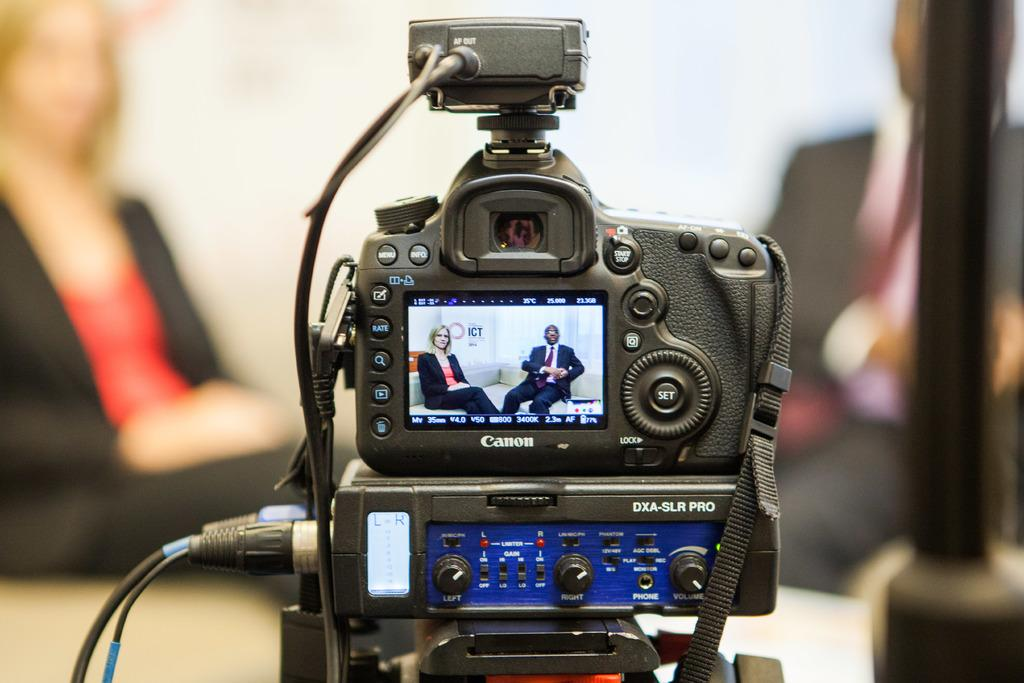What is the main object in the image? There is a camera with a screen in the image. Who is present in the image? A man and a woman are sitting on the backside of the camera. What can be seen in the background of the image? There is a wall visible in the image. What is located on the right side of the image? There is a pole on the right side of the image. How does the rat feel about the camera in the image? There is no rat present in the image, so it is not possible to determine how a rat might feel about the camera. 